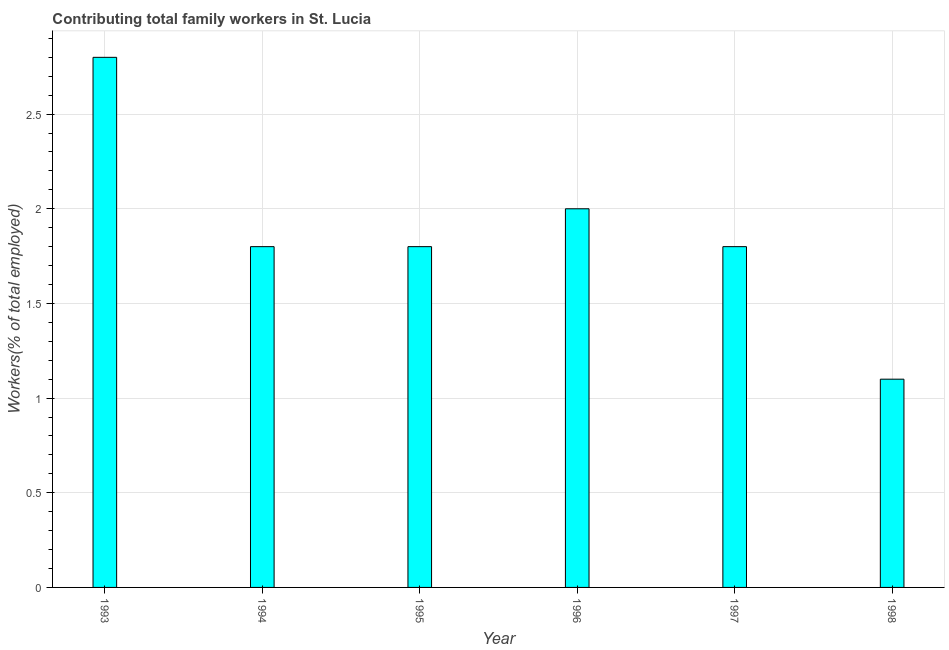Does the graph contain any zero values?
Make the answer very short. No. What is the title of the graph?
Keep it short and to the point. Contributing total family workers in St. Lucia. What is the label or title of the X-axis?
Provide a succinct answer. Year. What is the label or title of the Y-axis?
Offer a terse response. Workers(% of total employed). What is the contributing family workers in 1993?
Offer a very short reply. 2.8. Across all years, what is the maximum contributing family workers?
Ensure brevity in your answer.  2.8. Across all years, what is the minimum contributing family workers?
Your answer should be compact. 1.1. In which year was the contributing family workers maximum?
Your answer should be very brief. 1993. In which year was the contributing family workers minimum?
Ensure brevity in your answer.  1998. What is the sum of the contributing family workers?
Make the answer very short. 11.3. What is the average contributing family workers per year?
Offer a terse response. 1.88. What is the median contributing family workers?
Make the answer very short. 1.8. In how many years, is the contributing family workers greater than 2.8 %?
Make the answer very short. 0. Do a majority of the years between 1998 and 1997 (inclusive) have contributing family workers greater than 2 %?
Your answer should be compact. No. What is the ratio of the contributing family workers in 1996 to that in 1998?
Provide a short and direct response. 1.82. How many bars are there?
Keep it short and to the point. 6. How many years are there in the graph?
Provide a succinct answer. 6. Are the values on the major ticks of Y-axis written in scientific E-notation?
Keep it short and to the point. No. What is the Workers(% of total employed) in 1993?
Provide a short and direct response. 2.8. What is the Workers(% of total employed) of 1994?
Offer a terse response. 1.8. What is the Workers(% of total employed) in 1995?
Give a very brief answer. 1.8. What is the Workers(% of total employed) in 1997?
Give a very brief answer. 1.8. What is the Workers(% of total employed) of 1998?
Make the answer very short. 1.1. What is the difference between the Workers(% of total employed) in 1993 and 1994?
Your response must be concise. 1. What is the difference between the Workers(% of total employed) in 1993 and 1997?
Your answer should be compact. 1. What is the difference between the Workers(% of total employed) in 1994 and 1996?
Provide a short and direct response. -0.2. What is the difference between the Workers(% of total employed) in 1997 and 1998?
Offer a very short reply. 0.7. What is the ratio of the Workers(% of total employed) in 1993 to that in 1994?
Your answer should be compact. 1.56. What is the ratio of the Workers(% of total employed) in 1993 to that in 1995?
Your answer should be compact. 1.56. What is the ratio of the Workers(% of total employed) in 1993 to that in 1997?
Your answer should be compact. 1.56. What is the ratio of the Workers(% of total employed) in 1993 to that in 1998?
Keep it short and to the point. 2.54. What is the ratio of the Workers(% of total employed) in 1994 to that in 1995?
Provide a short and direct response. 1. What is the ratio of the Workers(% of total employed) in 1994 to that in 1998?
Ensure brevity in your answer.  1.64. What is the ratio of the Workers(% of total employed) in 1995 to that in 1996?
Offer a terse response. 0.9. What is the ratio of the Workers(% of total employed) in 1995 to that in 1998?
Offer a very short reply. 1.64. What is the ratio of the Workers(% of total employed) in 1996 to that in 1997?
Your answer should be very brief. 1.11. What is the ratio of the Workers(% of total employed) in 1996 to that in 1998?
Ensure brevity in your answer.  1.82. What is the ratio of the Workers(% of total employed) in 1997 to that in 1998?
Keep it short and to the point. 1.64. 